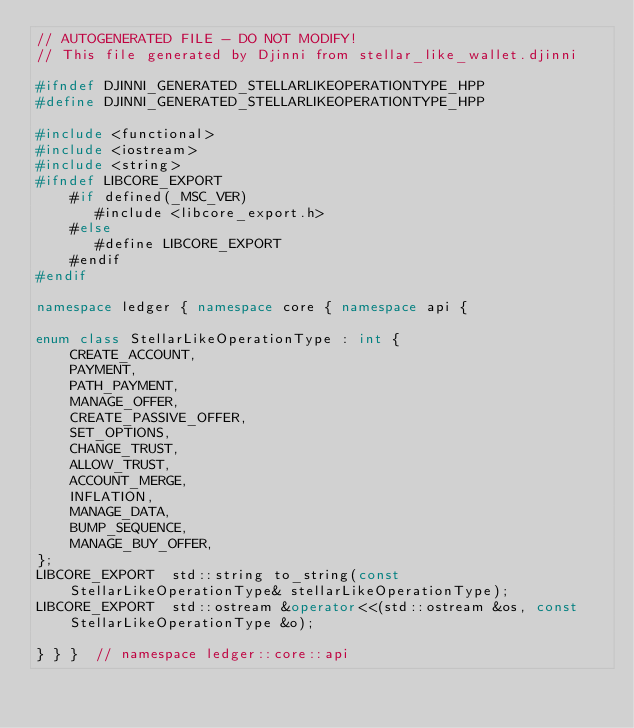<code> <loc_0><loc_0><loc_500><loc_500><_C++_>// AUTOGENERATED FILE - DO NOT MODIFY!
// This file generated by Djinni from stellar_like_wallet.djinni

#ifndef DJINNI_GENERATED_STELLARLIKEOPERATIONTYPE_HPP
#define DJINNI_GENERATED_STELLARLIKEOPERATIONTYPE_HPP

#include <functional>
#include <iostream>
#include <string>
#ifndef LIBCORE_EXPORT
    #if defined(_MSC_VER)
       #include <libcore_export.h>
    #else
       #define LIBCORE_EXPORT
    #endif
#endif

namespace ledger { namespace core { namespace api {

enum class StellarLikeOperationType : int {
    CREATE_ACCOUNT,
    PAYMENT,
    PATH_PAYMENT,
    MANAGE_OFFER,
    CREATE_PASSIVE_OFFER,
    SET_OPTIONS,
    CHANGE_TRUST,
    ALLOW_TRUST,
    ACCOUNT_MERGE,
    INFLATION,
    MANAGE_DATA,
    BUMP_SEQUENCE,
    MANAGE_BUY_OFFER,
};
LIBCORE_EXPORT  std::string to_string(const StellarLikeOperationType& stellarLikeOperationType);
LIBCORE_EXPORT  std::ostream &operator<<(std::ostream &os, const StellarLikeOperationType &o);

} } }  // namespace ledger::core::api
</code> 